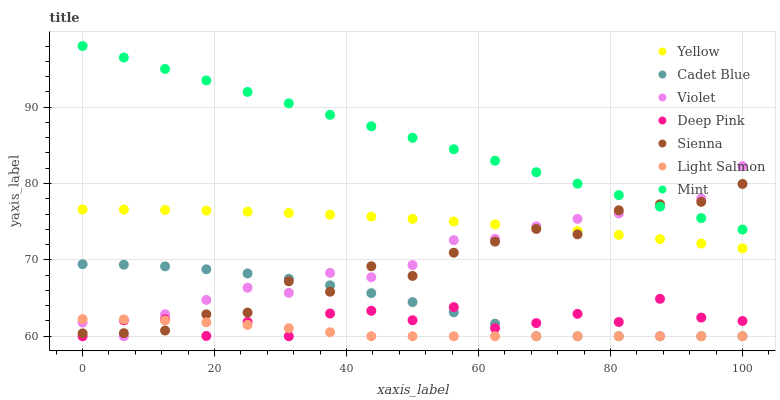Does Light Salmon have the minimum area under the curve?
Answer yes or no. Yes. Does Mint have the maximum area under the curve?
Answer yes or no. Yes. Does Cadet Blue have the minimum area under the curve?
Answer yes or no. No. Does Cadet Blue have the maximum area under the curve?
Answer yes or no. No. Is Mint the smoothest?
Answer yes or no. Yes. Is Deep Pink the roughest?
Answer yes or no. Yes. Is Cadet Blue the smoothest?
Answer yes or no. No. Is Cadet Blue the roughest?
Answer yes or no. No. Does Light Salmon have the lowest value?
Answer yes or no. Yes. Does Yellow have the lowest value?
Answer yes or no. No. Does Mint have the highest value?
Answer yes or no. Yes. Does Cadet Blue have the highest value?
Answer yes or no. No. Is Yellow less than Mint?
Answer yes or no. Yes. Is Mint greater than Yellow?
Answer yes or no. Yes. Does Yellow intersect Sienna?
Answer yes or no. Yes. Is Yellow less than Sienna?
Answer yes or no. No. Is Yellow greater than Sienna?
Answer yes or no. No. Does Yellow intersect Mint?
Answer yes or no. No. 